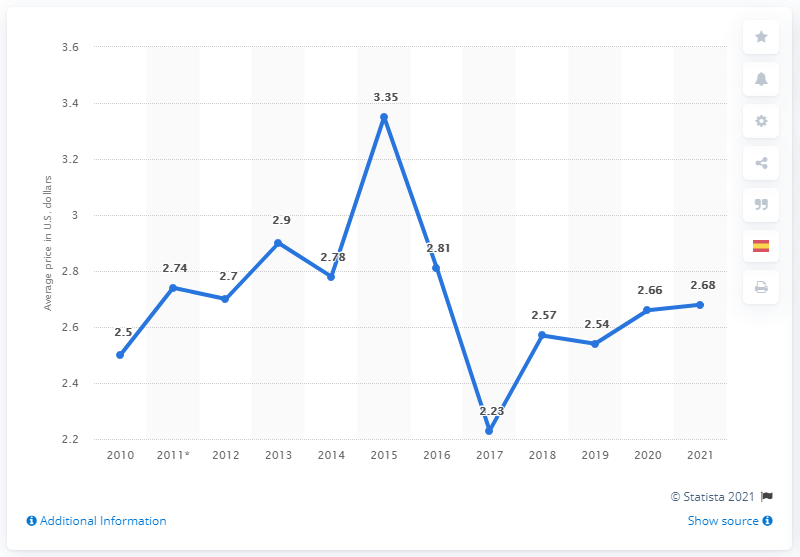Mention a couple of crucial points in this snapshot. The average price for a Big Mac burger in Mexico during January 2021 was 2.68. 